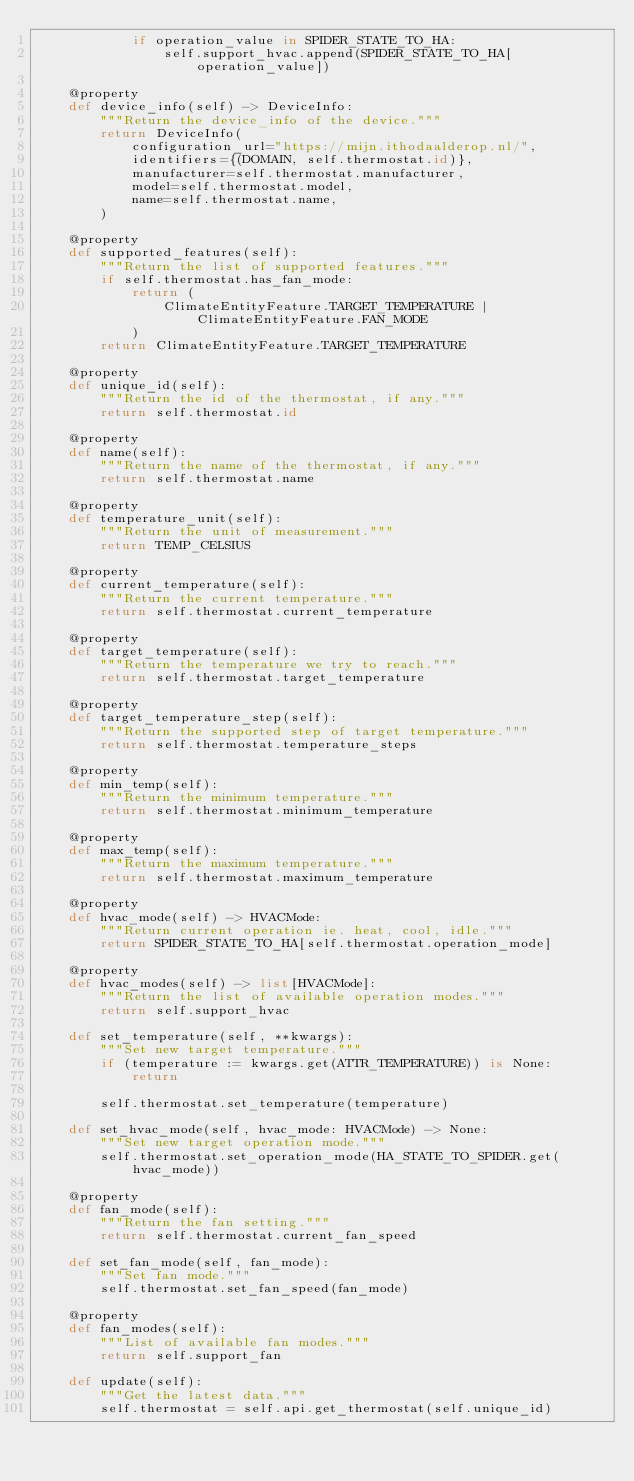Convert code to text. <code><loc_0><loc_0><loc_500><loc_500><_Python_>            if operation_value in SPIDER_STATE_TO_HA:
                self.support_hvac.append(SPIDER_STATE_TO_HA[operation_value])

    @property
    def device_info(self) -> DeviceInfo:
        """Return the device_info of the device."""
        return DeviceInfo(
            configuration_url="https://mijn.ithodaalderop.nl/",
            identifiers={(DOMAIN, self.thermostat.id)},
            manufacturer=self.thermostat.manufacturer,
            model=self.thermostat.model,
            name=self.thermostat.name,
        )

    @property
    def supported_features(self):
        """Return the list of supported features."""
        if self.thermostat.has_fan_mode:
            return (
                ClimateEntityFeature.TARGET_TEMPERATURE | ClimateEntityFeature.FAN_MODE
            )
        return ClimateEntityFeature.TARGET_TEMPERATURE

    @property
    def unique_id(self):
        """Return the id of the thermostat, if any."""
        return self.thermostat.id

    @property
    def name(self):
        """Return the name of the thermostat, if any."""
        return self.thermostat.name

    @property
    def temperature_unit(self):
        """Return the unit of measurement."""
        return TEMP_CELSIUS

    @property
    def current_temperature(self):
        """Return the current temperature."""
        return self.thermostat.current_temperature

    @property
    def target_temperature(self):
        """Return the temperature we try to reach."""
        return self.thermostat.target_temperature

    @property
    def target_temperature_step(self):
        """Return the supported step of target temperature."""
        return self.thermostat.temperature_steps

    @property
    def min_temp(self):
        """Return the minimum temperature."""
        return self.thermostat.minimum_temperature

    @property
    def max_temp(self):
        """Return the maximum temperature."""
        return self.thermostat.maximum_temperature

    @property
    def hvac_mode(self) -> HVACMode:
        """Return current operation ie. heat, cool, idle."""
        return SPIDER_STATE_TO_HA[self.thermostat.operation_mode]

    @property
    def hvac_modes(self) -> list[HVACMode]:
        """Return the list of available operation modes."""
        return self.support_hvac

    def set_temperature(self, **kwargs):
        """Set new target temperature."""
        if (temperature := kwargs.get(ATTR_TEMPERATURE)) is None:
            return

        self.thermostat.set_temperature(temperature)

    def set_hvac_mode(self, hvac_mode: HVACMode) -> None:
        """Set new target operation mode."""
        self.thermostat.set_operation_mode(HA_STATE_TO_SPIDER.get(hvac_mode))

    @property
    def fan_mode(self):
        """Return the fan setting."""
        return self.thermostat.current_fan_speed

    def set_fan_mode(self, fan_mode):
        """Set fan mode."""
        self.thermostat.set_fan_speed(fan_mode)

    @property
    def fan_modes(self):
        """List of available fan modes."""
        return self.support_fan

    def update(self):
        """Get the latest data."""
        self.thermostat = self.api.get_thermostat(self.unique_id)
</code> 